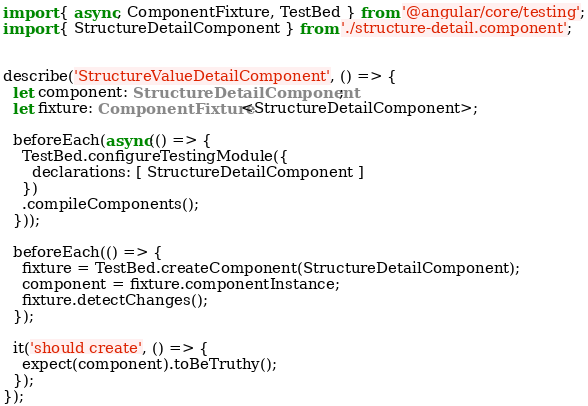Convert code to text. <code><loc_0><loc_0><loc_500><loc_500><_TypeScript_>import { async, ComponentFixture, TestBed } from '@angular/core/testing';
import { StructureDetailComponent } from './structure-detail.component';


describe('StructureValueDetailComponent', () => {
  let component: StructureDetailComponent;
  let fixture: ComponentFixture<StructureDetailComponent>;

  beforeEach(async(() => {
    TestBed.configureTestingModule({
      declarations: [ StructureDetailComponent ]
    })
    .compileComponents();
  }));

  beforeEach(() => {
    fixture = TestBed.createComponent(StructureDetailComponent);
    component = fixture.componentInstance;
    fixture.detectChanges();
  });

  it('should create', () => {
    expect(component).toBeTruthy();
  });
});
</code> 